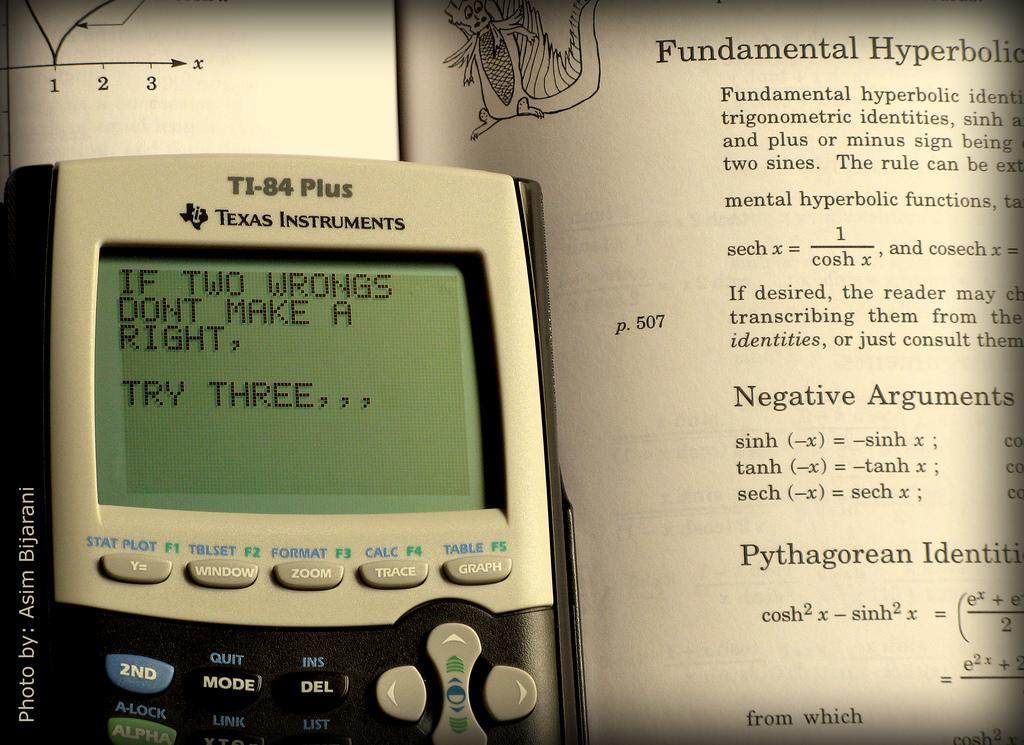Provide a one-sentence caption for the provided image. a smart phone with "Two wrongs don't make a right" displayed on it. 